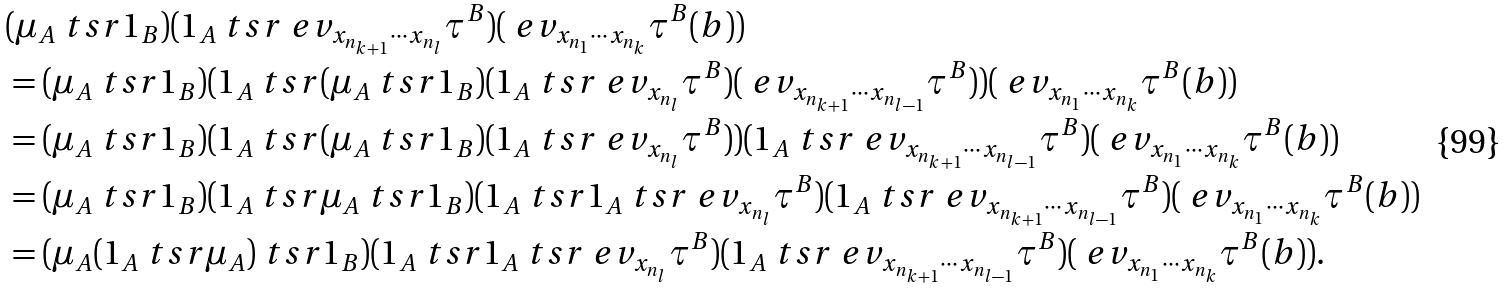<formula> <loc_0><loc_0><loc_500><loc_500>& ( \mu _ { A } \ t s r 1 _ { B } ) ( 1 _ { A } \ t s r \ e v _ { x _ { n _ { k + 1 } } \cdots x _ { n _ { l } } } \tau ^ { B } ) ( \ e v _ { x _ { n _ { 1 } } \cdots x _ { n _ { k } } } \tau ^ { B } ( b ) ) \\ & = ( \mu _ { A } \ t s r 1 _ { B } ) ( 1 _ { A } \ t s r ( \mu _ { A } \ t s r 1 _ { B } ) ( 1 _ { A } \ t s r \ e v _ { x _ { n _ { l } } } \tau ^ { B } ) ( \ e v _ { x _ { n _ { k + 1 } } \cdots x _ { n _ { l - 1 } } } \tau ^ { B } ) ) ( \ e v _ { x _ { n _ { 1 } } \cdots x _ { n _ { k } } } \tau ^ { B } ( b ) ) \\ & = ( \mu _ { A } \ t s r 1 _ { B } ) ( 1 _ { A } \ t s r ( \mu _ { A } \ t s r 1 _ { B } ) ( 1 _ { A } \ t s r \ e v _ { x _ { n _ { l } } } \tau ^ { B } ) ) ( 1 _ { A } \ t s r \ e v _ { x _ { n _ { k + 1 } } \cdots x _ { n _ { l - 1 } } } \tau ^ { B } ) ( \ e v _ { x _ { n _ { 1 } } \cdots x _ { n _ { k } } } \tau ^ { B } ( b ) ) \\ & = ( \mu _ { A } \ t s r 1 _ { B } ) ( 1 _ { A } \ t s r \mu _ { A } \ t s r 1 _ { B } ) ( 1 _ { A } \ t s r 1 _ { A } \ t s r \ e v _ { x _ { n _ { l } } } \tau ^ { B } ) ( 1 _ { A } \ t s r \ e v _ { x _ { n _ { k + 1 } } \cdots x _ { n _ { l - 1 } } } \tau ^ { B } ) ( \ e v _ { x _ { n _ { 1 } } \cdots x _ { n _ { k } } } \tau ^ { B } ( b ) ) \\ & = ( \mu _ { A } ( 1 _ { A } \ t s r \mu _ { A } ) \ t s r 1 _ { B } ) ( 1 _ { A } \ t s r 1 _ { A } \ t s r \ e v _ { x _ { n _ { l } } } \tau ^ { B } ) ( 1 _ { A } \ t s r \ e v _ { x _ { n _ { k + 1 } } \cdots x _ { n _ { l - 1 } } } \tau ^ { B } ) ( \ e v _ { x _ { n _ { 1 } } \cdots x _ { n _ { k } } } \tau ^ { B } ( b ) ) . \\</formula> 